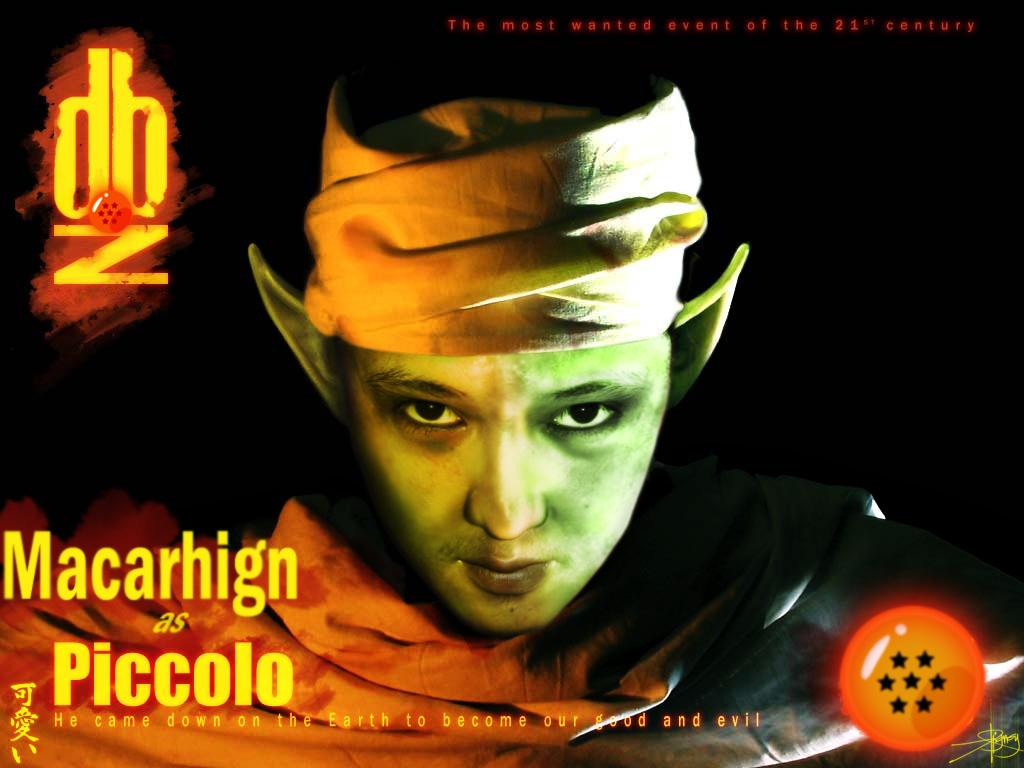What is the main subject in the foreground of the image? There is a man in the foreground of the image. What else can be seen in the foreground of the image besides the man? There is text in the foreground of the image. How does the cabbage increase in size in the image? There is no cabbage present in the image, so it cannot increase in size. 